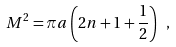Convert formula to latex. <formula><loc_0><loc_0><loc_500><loc_500>M ^ { 2 } = \pi a \left ( 2 n + 1 + \frac { 1 } { 2 } \right ) \ ,</formula> 